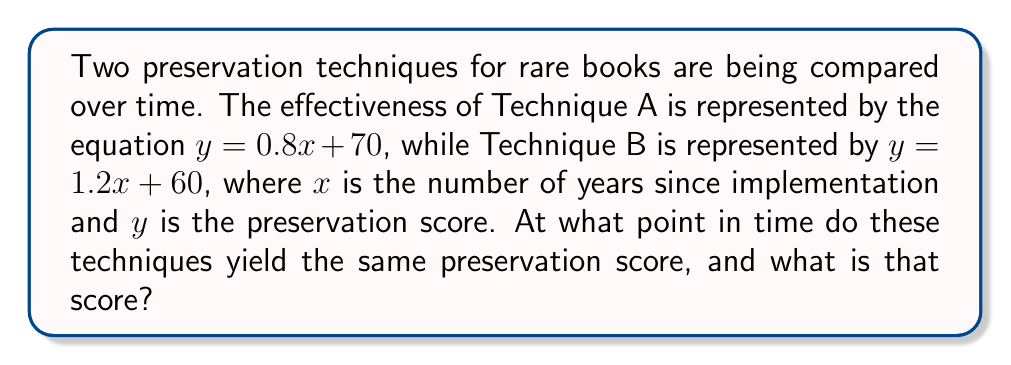Show me your answer to this math problem. To find the intersection point of these two trend lines, we need to solve the system of equations:

$$\begin{cases}
y = 0.8x + 70 \\
y = 1.2x + 60
\end{cases}$$

1) Since both equations equal $y$, we can set them equal to each other:
   $0.8x + 70 = 1.2x + 60$

2) Subtract $0.8x$ from both sides:
   $70 = 0.4x + 60$

3) Subtract 60 from both sides:
   $10 = 0.4x$

4) Divide both sides by 0.4:
   $25 = x$

5) Now that we know $x$, we can substitute it into either original equation to find $y$. Let's use the first equation:
   $y = 0.8(25) + 70 = 20 + 70 = 90$

Therefore, the intersection point is at $(25, 90)$.
Answer: (25, 90) 